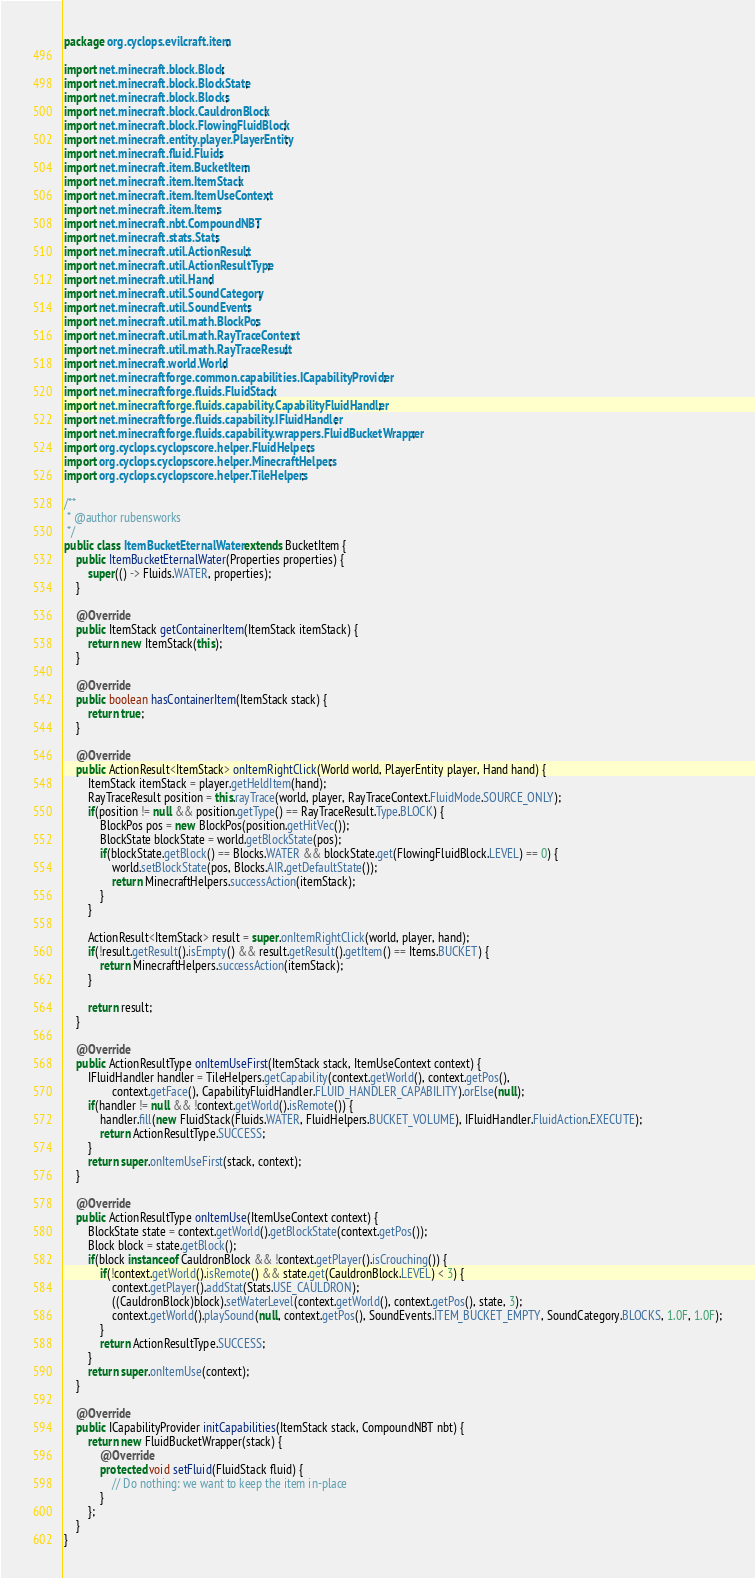Convert code to text. <code><loc_0><loc_0><loc_500><loc_500><_Java_>package org.cyclops.evilcraft.item;

import net.minecraft.block.Block;
import net.minecraft.block.BlockState;
import net.minecraft.block.Blocks;
import net.minecraft.block.CauldronBlock;
import net.minecraft.block.FlowingFluidBlock;
import net.minecraft.entity.player.PlayerEntity;
import net.minecraft.fluid.Fluids;
import net.minecraft.item.BucketItem;
import net.minecraft.item.ItemStack;
import net.minecraft.item.ItemUseContext;
import net.minecraft.item.Items;
import net.minecraft.nbt.CompoundNBT;
import net.minecraft.stats.Stats;
import net.minecraft.util.ActionResult;
import net.minecraft.util.ActionResultType;
import net.minecraft.util.Hand;
import net.minecraft.util.SoundCategory;
import net.minecraft.util.SoundEvents;
import net.minecraft.util.math.BlockPos;
import net.minecraft.util.math.RayTraceContext;
import net.minecraft.util.math.RayTraceResult;
import net.minecraft.world.World;
import net.minecraftforge.common.capabilities.ICapabilityProvider;
import net.minecraftforge.fluids.FluidStack;
import net.minecraftforge.fluids.capability.CapabilityFluidHandler;
import net.minecraftforge.fluids.capability.IFluidHandler;
import net.minecraftforge.fluids.capability.wrappers.FluidBucketWrapper;
import org.cyclops.cyclopscore.helper.FluidHelpers;
import org.cyclops.cyclopscore.helper.MinecraftHelpers;
import org.cyclops.cyclopscore.helper.TileHelpers;

/**
 * @author rubensworks
 */
public class ItemBucketEternalWater extends BucketItem {
    public ItemBucketEternalWater(Properties properties) {
        super(() -> Fluids.WATER, properties);
    }

    @Override
    public ItemStack getContainerItem(ItemStack itemStack) {
        return new ItemStack(this);
    }

    @Override
    public boolean hasContainerItem(ItemStack stack) {
        return true;
    }

    @Override
    public ActionResult<ItemStack> onItemRightClick(World world, PlayerEntity player, Hand hand) {
        ItemStack itemStack = player.getHeldItem(hand);
        RayTraceResult position = this.rayTrace(world, player, RayTraceContext.FluidMode.SOURCE_ONLY);
        if(position != null && position.getType() == RayTraceResult.Type.BLOCK) {
            BlockPos pos = new BlockPos(position.getHitVec());
            BlockState blockState = world.getBlockState(pos);
            if(blockState.getBlock() == Blocks.WATER && blockState.get(FlowingFluidBlock.LEVEL) == 0) {
                world.setBlockState(pos, Blocks.AIR.getDefaultState());
                return MinecraftHelpers.successAction(itemStack);
            }
        }

        ActionResult<ItemStack> result = super.onItemRightClick(world, player, hand);
        if(!result.getResult().isEmpty() && result.getResult().getItem() == Items.BUCKET) {
            return MinecraftHelpers.successAction(itemStack);
        }

        return result;
    }

    @Override
    public ActionResultType onItemUseFirst(ItemStack stack, ItemUseContext context) {
        IFluidHandler handler = TileHelpers.getCapability(context.getWorld(), context.getPos(),
                context.getFace(), CapabilityFluidHandler.FLUID_HANDLER_CAPABILITY).orElse(null);
        if(handler != null && !context.getWorld().isRemote()) {
            handler.fill(new FluidStack(Fluids.WATER, FluidHelpers.BUCKET_VOLUME), IFluidHandler.FluidAction.EXECUTE);
            return ActionResultType.SUCCESS;
        }
        return super.onItemUseFirst(stack, context);
    }

    @Override
    public ActionResultType onItemUse(ItemUseContext context) {
        BlockState state = context.getWorld().getBlockState(context.getPos());
        Block block = state.getBlock();
        if(block instanceof CauldronBlock && !context.getPlayer().isCrouching()) {
            if(!context.getWorld().isRemote() && state.get(CauldronBlock.LEVEL) < 3) {
                context.getPlayer().addStat(Stats.USE_CAULDRON);
                ((CauldronBlock)block).setWaterLevel(context.getWorld(), context.getPos(), state, 3);
                context.getWorld().playSound(null, context.getPos(), SoundEvents.ITEM_BUCKET_EMPTY, SoundCategory.BLOCKS, 1.0F, 1.0F);
            }
            return ActionResultType.SUCCESS;
        }
        return super.onItemUse(context);
    }

    @Override
    public ICapabilityProvider initCapabilities(ItemStack stack, CompoundNBT nbt) {
        return new FluidBucketWrapper(stack) {
            @Override
            protected void setFluid(FluidStack fluid) {
                // Do nothing: we want to keep the item in-place
            }
        };
    }
}
</code> 